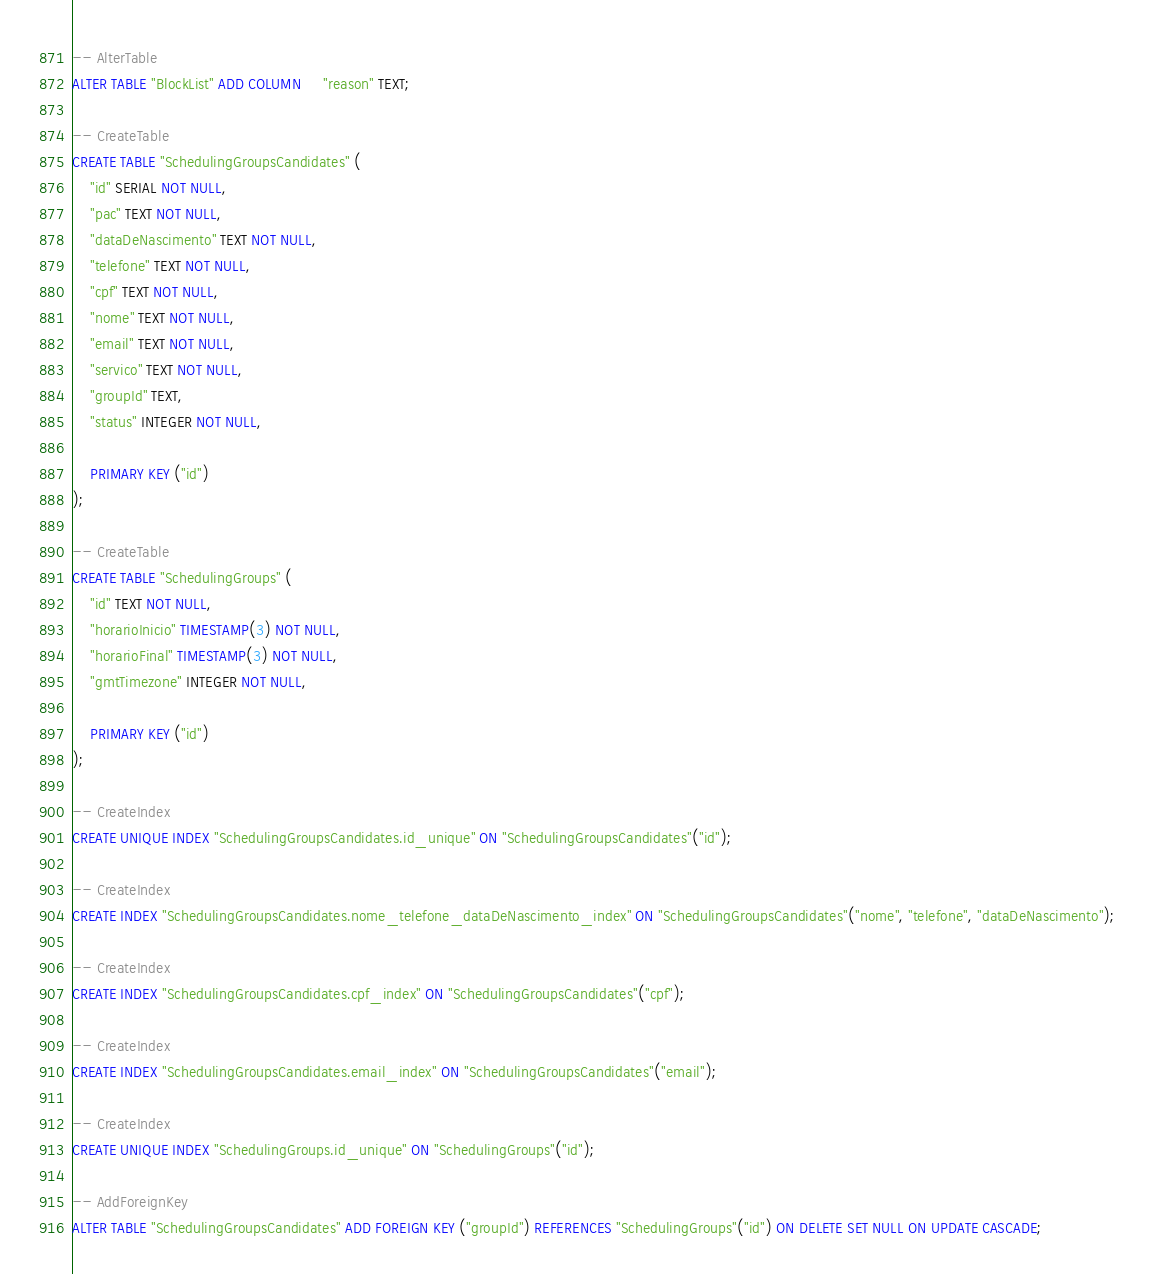<code> <loc_0><loc_0><loc_500><loc_500><_SQL_>-- AlterTable
ALTER TABLE "BlockList" ADD COLUMN     "reason" TEXT;

-- CreateTable
CREATE TABLE "SchedulingGroupsCandidates" (
    "id" SERIAL NOT NULL,
    "pac" TEXT NOT NULL,
    "dataDeNascimento" TEXT NOT NULL,
    "telefone" TEXT NOT NULL,
    "cpf" TEXT NOT NULL,
    "nome" TEXT NOT NULL,
    "email" TEXT NOT NULL,
    "servico" TEXT NOT NULL,
    "groupId" TEXT,
    "status" INTEGER NOT NULL,

    PRIMARY KEY ("id")
);

-- CreateTable
CREATE TABLE "SchedulingGroups" (
    "id" TEXT NOT NULL,
    "horarioInicio" TIMESTAMP(3) NOT NULL,
    "horarioFinal" TIMESTAMP(3) NOT NULL,
    "gmtTimezone" INTEGER NOT NULL,

    PRIMARY KEY ("id")
);

-- CreateIndex
CREATE UNIQUE INDEX "SchedulingGroupsCandidates.id_unique" ON "SchedulingGroupsCandidates"("id");

-- CreateIndex
CREATE INDEX "SchedulingGroupsCandidates.nome_telefone_dataDeNascimento_index" ON "SchedulingGroupsCandidates"("nome", "telefone", "dataDeNascimento");

-- CreateIndex
CREATE INDEX "SchedulingGroupsCandidates.cpf_index" ON "SchedulingGroupsCandidates"("cpf");

-- CreateIndex
CREATE INDEX "SchedulingGroupsCandidates.email_index" ON "SchedulingGroupsCandidates"("email");

-- CreateIndex
CREATE UNIQUE INDEX "SchedulingGroups.id_unique" ON "SchedulingGroups"("id");

-- AddForeignKey
ALTER TABLE "SchedulingGroupsCandidates" ADD FOREIGN KEY ("groupId") REFERENCES "SchedulingGroups"("id") ON DELETE SET NULL ON UPDATE CASCADE;
</code> 